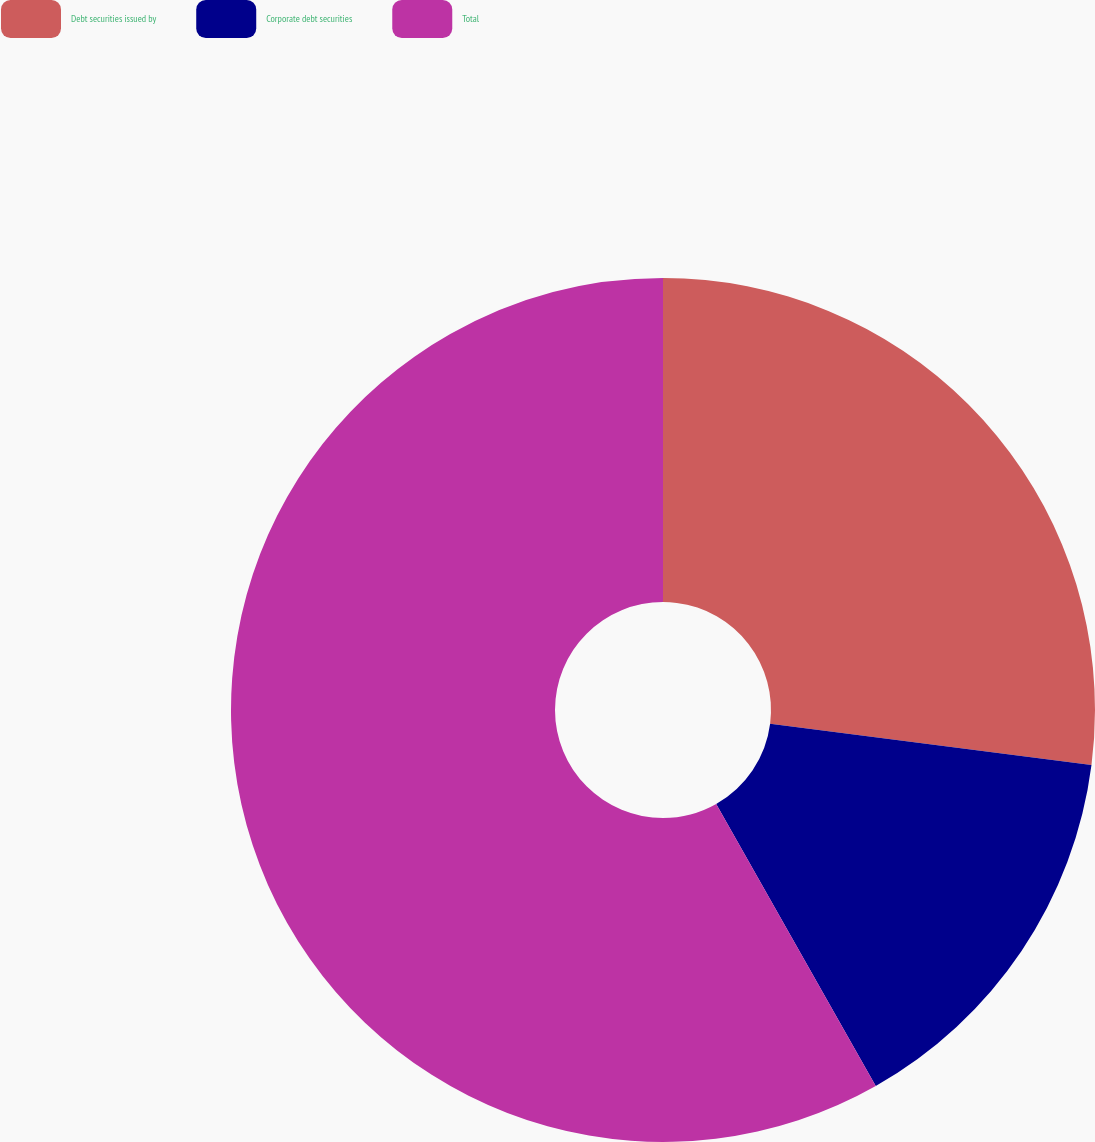<chart> <loc_0><loc_0><loc_500><loc_500><pie_chart><fcel>Debt securities issued by<fcel>Corporate debt securities<fcel>Total<nl><fcel>27.03%<fcel>14.77%<fcel>58.19%<nl></chart> 